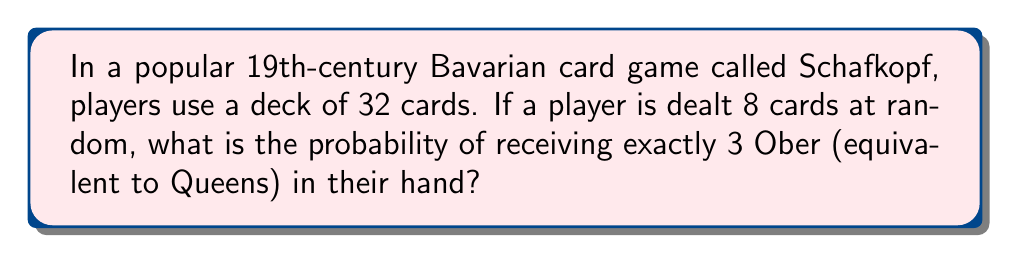Help me with this question. To solve this problem, we'll use the hypergeometric distribution, which is appropriate for calculating probabilities in situations involving sampling without replacement.

Let's define our parameters:
- N = 32 (total number of cards in the deck)
- K = 4 (total number of Ober in the deck)
- n = 8 (number of cards dealt to the player)
- k = 3 (number of Ober we're interested in)

The probability of getting exactly k successes in n draws from a population of size N containing K successes is given by the formula:

$$ P(X = k) = \frac{\binom{K}{k} \binom{N-K}{n-k}}{\binom{N}{n}} $$

Where $\binom{a}{b}$ represents the binomial coefficient, calculated as:

$$ \binom{a}{b} = \frac{a!}{b!(a-b)!} $$

Let's calculate each part:

1) $\binom{K}{k} = \binom{4}{3} = \frac{4!}{3!(4-3)!} = 4$

2) $\binom{N-K}{n-k} = \binom{28}{5} = \frac{28!}{5!(28-5)!} = 98,280$

3) $\binom{N}{n} = \binom{32}{8} = \frac{32!}{8!(32-8)!} = 10,518,300$

Now, let's plug these values into our main formula:

$$ P(X = 3) = \frac{4 \times 98,280}{10,518,300} = \frac{393,120}{10,518,300} \approx 0.0374 $$
Answer: The probability of receiving exactly 3 Ober in a hand of 8 cards in Schafkopf is approximately 0.0374 or 3.74%. 